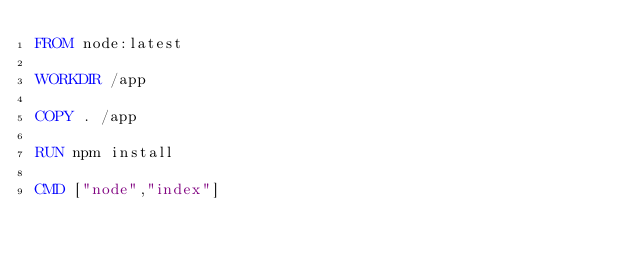<code> <loc_0><loc_0><loc_500><loc_500><_Dockerfile_>FROM node:latest

WORKDIR /app

COPY . /app

RUN npm install

CMD ["node","index"]
</code> 